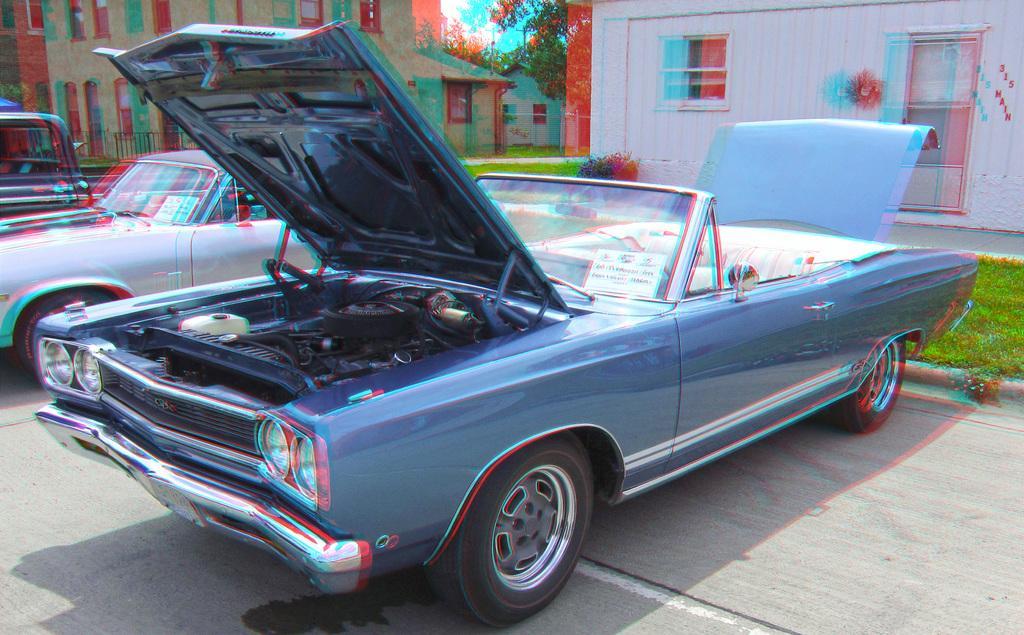Could you give a brief overview of what you see in this image? In this image we can see a few cars and posters with some texts written on it, there are some houses, windows, trees, grass, and the clouded sky. 